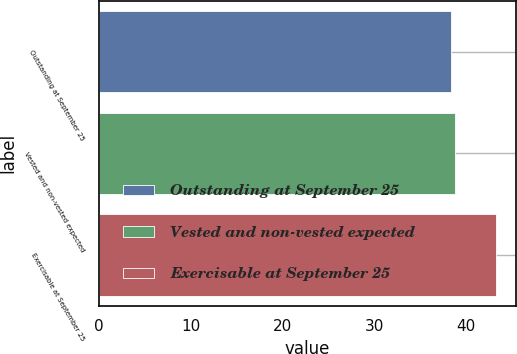Convert chart. <chart><loc_0><loc_0><loc_500><loc_500><bar_chart><fcel>Outstanding at September 25<fcel>Vested and non-vested expected<fcel>Exercisable at September 25<nl><fcel>38.3<fcel>38.8<fcel>43.26<nl></chart> 